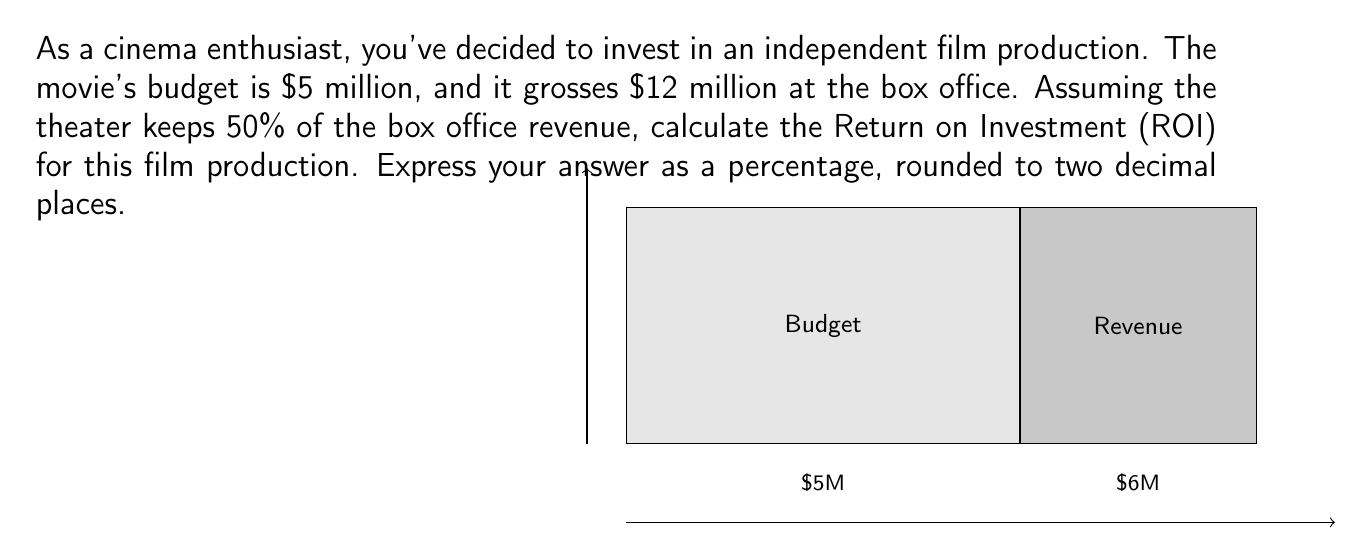What is the answer to this math problem? Let's break this down step-by-step:

1) First, we need to calculate the net revenue from the film:
   - Gross box office: $12 million
   - Theater's share (50%): $12 million × 0.5 = $6 million
   - Film's revenue: $12 million - $6 million = $6 million

2) Now, we can calculate the profit:
   Profit = Revenue - Cost
   $$\text{Profit} = \$6 \text{ million} - \$5 \text{ million} = \$1 \text{ million}$$

3) The Return on Investment (ROI) formula is:
   $$\text{ROI} = \frac{\text{Profit}}{\text{Cost of Investment}} \times 100\%$$

4) Plugging in our values:
   $$\text{ROI} = \frac{\$1 \text{ million}}{\$5 \text{ million}} \times 100\%$$

5) Simplifying:
   $$\text{ROI} = 0.2 \times 100\% = 20\%$$

Therefore, the ROI for this film production is 20.00%.
Answer: 20.00% 